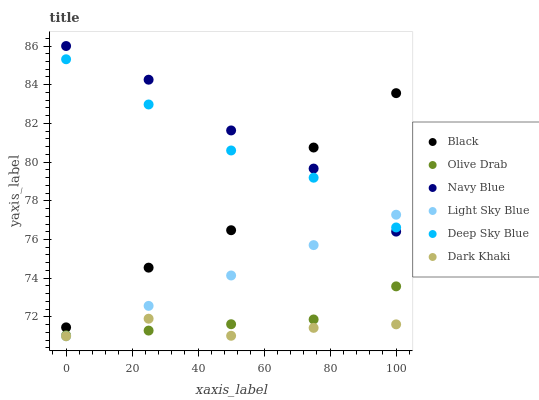Does Dark Khaki have the minimum area under the curve?
Answer yes or no. Yes. Does Navy Blue have the maximum area under the curve?
Answer yes or no. Yes. Does Light Sky Blue have the minimum area under the curve?
Answer yes or no. No. Does Light Sky Blue have the maximum area under the curve?
Answer yes or no. No. Is Light Sky Blue the smoothest?
Answer yes or no. Yes. Is Black the roughest?
Answer yes or no. Yes. Is Dark Khaki the smoothest?
Answer yes or no. No. Is Dark Khaki the roughest?
Answer yes or no. No. Does Dark Khaki have the lowest value?
Answer yes or no. Yes. Does Black have the lowest value?
Answer yes or no. No. Does Navy Blue have the highest value?
Answer yes or no. Yes. Does Light Sky Blue have the highest value?
Answer yes or no. No. Is Dark Khaki less than Navy Blue?
Answer yes or no. Yes. Is Navy Blue greater than Olive Drab?
Answer yes or no. Yes. Does Olive Drab intersect Dark Khaki?
Answer yes or no. Yes. Is Olive Drab less than Dark Khaki?
Answer yes or no. No. Is Olive Drab greater than Dark Khaki?
Answer yes or no. No. Does Dark Khaki intersect Navy Blue?
Answer yes or no. No. 